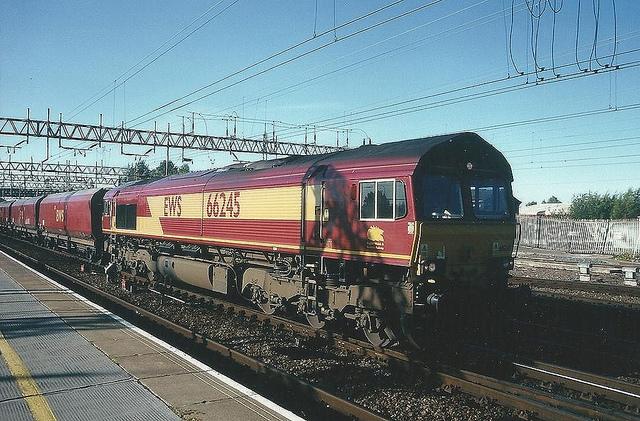Is this a passenger train?
Be succinct. No. What kind of locomotive is this?
Give a very brief answer. Electric. Can the engineer of the train be seen?
Quick response, please. No. What color is the train?
Concise answer only. Red and yellow. What color is this transportation?
Quick response, please. Red. Is the sky overcast?
Be succinct. No. 